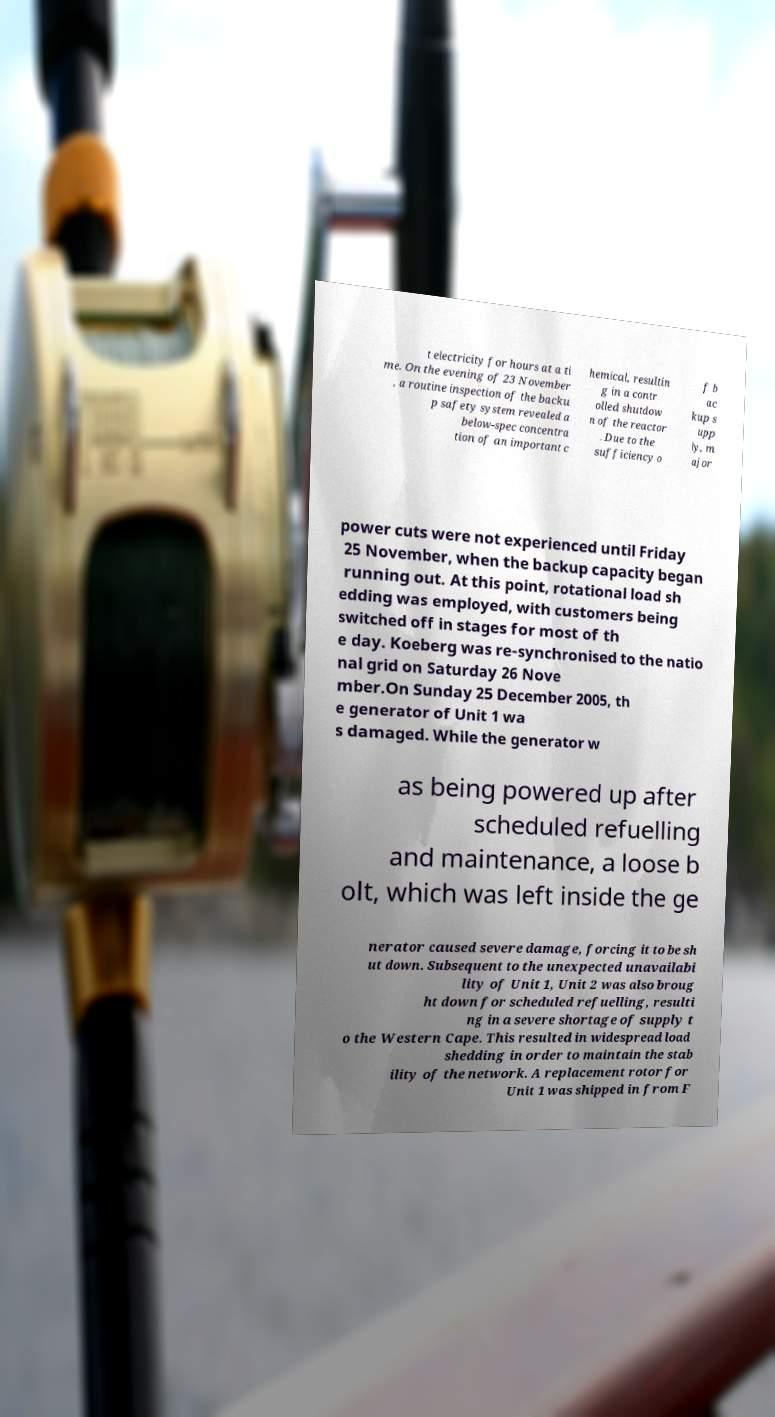Please read and relay the text visible in this image. What does it say? t electricity for hours at a ti me. On the evening of 23 November , a routine inspection of the backu p safety system revealed a below-spec concentra tion of an important c hemical, resultin g in a contr olled shutdow n of the reactor . Due to the sufficiency o f b ac kup s upp ly, m ajor power cuts were not experienced until Friday 25 November, when the backup capacity began running out. At this point, rotational load sh edding was employed, with customers being switched off in stages for most of th e day. Koeberg was re-synchronised to the natio nal grid on Saturday 26 Nove mber.On Sunday 25 December 2005, th e generator of Unit 1 wa s damaged. While the generator w as being powered up after scheduled refuelling and maintenance, a loose b olt, which was left inside the ge nerator caused severe damage, forcing it to be sh ut down. Subsequent to the unexpected unavailabi lity of Unit 1, Unit 2 was also broug ht down for scheduled refuelling, resulti ng in a severe shortage of supply t o the Western Cape. This resulted in widespread load shedding in order to maintain the stab ility of the network. A replacement rotor for Unit 1 was shipped in from F 